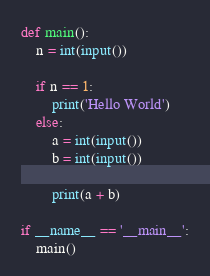<code> <loc_0><loc_0><loc_500><loc_500><_Python_>def main():
    n = int(input())

    if n == 1:
        print('Hello World')
    else:
        a = int(input())
        b = int(input())

        print(a + b)

if __name__ == '__main__':
    main()</code> 